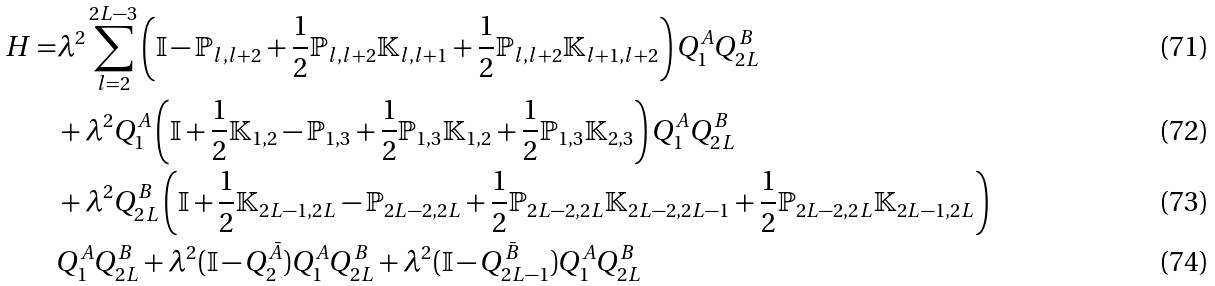Convert formula to latex. <formula><loc_0><loc_0><loc_500><loc_500>H = & \lambda ^ { 2 } \sum _ { l = 2 } ^ { 2 L - 3 } \left ( \mathbb { I } - \mathbb { P } _ { l , l + 2 } + \frac { 1 } { 2 } \mathbb { P } _ { l , l + 2 } \mathbb { K } _ { l , l + 1 } + \frac { 1 } { 2 } \mathbb { P } _ { l , l + 2 } \mathbb { K } _ { l + 1 , l + 2 } \right ) Q _ { 1 } ^ { A } Q _ { 2 L } ^ { B } \\ & + \lambda ^ { 2 } Q _ { 1 } ^ { A } \left ( \mathbb { I } + \frac { 1 } { 2 } \mathbb { K } _ { 1 , 2 } - \mathbb { P } _ { 1 , 3 } + \frac { 1 } { 2 } \mathbb { P } _ { 1 , 3 } \mathbb { K } _ { 1 , 2 } + \frac { 1 } { 2 } \mathbb { P } _ { 1 , 3 } \mathbb { K } _ { 2 , 3 } \right ) Q _ { 1 } ^ { A } Q _ { 2 L } ^ { B } \\ & + \lambda ^ { 2 } Q _ { 2 L } ^ { B } \left ( \mathbb { I } + \frac { 1 } { 2 } \mathbb { K } _ { 2 L - 1 , 2 L } - \mathbb { P } _ { 2 L - 2 , 2 L } + \frac { 1 } { 2 } \mathbb { P } _ { 2 L - 2 , 2 L } \mathbb { K } _ { 2 L - 2 , 2 L - 1 } + \frac { 1 } { 2 } \mathbb { P } _ { 2 L - 2 , 2 L } \mathbb { K } _ { 2 L - 1 , 2 L } \right ) \\ & Q _ { 1 } ^ { A } Q _ { 2 L } ^ { B } + \lambda ^ { 2 } ( \mathbb { I } - Q _ { 2 } ^ { \bar { A } } ) Q _ { 1 } ^ { A } Q _ { 2 L } ^ { B } + \lambda ^ { 2 } ( \mathbb { I } - Q _ { 2 L - 1 } ^ { \bar { B } } ) Q _ { 1 } ^ { A } Q _ { 2 L } ^ { B }</formula> 